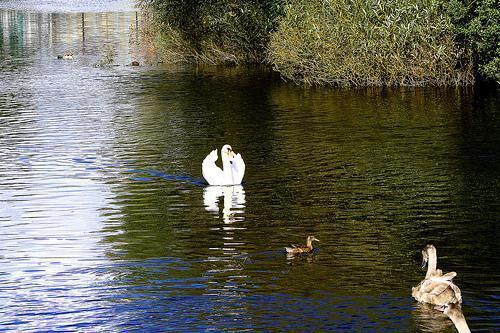How many birds are there?
Give a very brief answer. 3. 